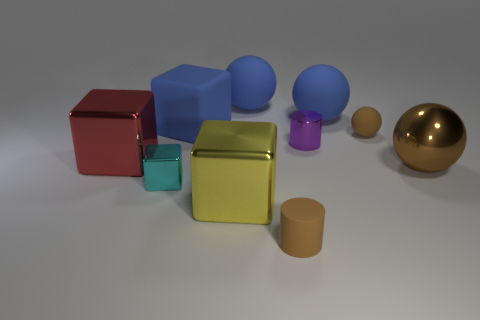What material is the cyan thing?
Your answer should be very brief. Metal. The small brown thing right of the small brown thing to the left of the brown thing that is behind the brown metallic ball is what shape?
Make the answer very short. Sphere. How many other objects are the same material as the tiny cyan block?
Provide a short and direct response. 4. Is the material of the small cylinder in front of the large brown shiny sphere the same as the large thing in front of the big brown shiny sphere?
Your answer should be compact. No. How many things are to the left of the yellow object and behind the tiny cyan shiny cube?
Ensure brevity in your answer.  2. Is there a gray metal object that has the same shape as the big red metal object?
Keep it short and to the point. No. What shape is the red metal object that is the same size as the brown metal thing?
Offer a very short reply. Cube. Are there the same number of metal balls left of the tiny metallic cylinder and brown cylinders that are behind the rubber cylinder?
Your response must be concise. Yes. There is a red metallic block to the left of the yellow metal cube that is on the right side of the small cyan metallic thing; what is its size?
Provide a short and direct response. Large. Are there any gray things of the same size as the purple object?
Your answer should be compact. No. 